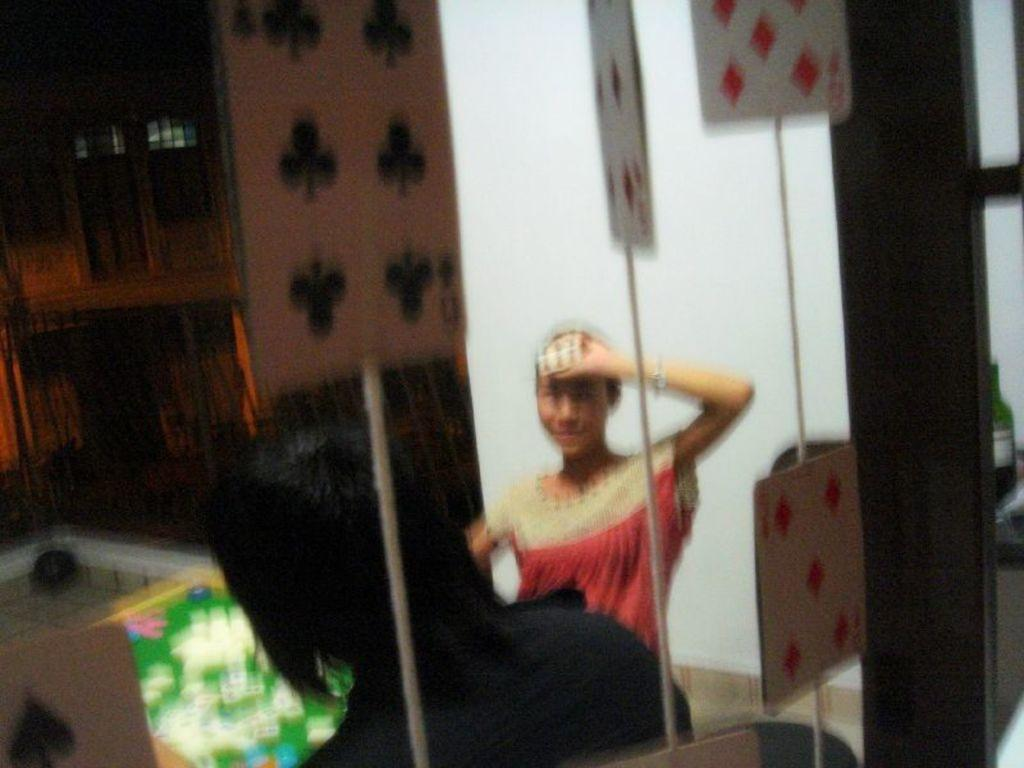How many people are in the image? There are two persons in the image. Can you describe one of the persons in the image? One of the persons is a woman. What is the woman doing with her hand in the image? The woman is holding a card with her hand. What can be seen in the background of the image? There are poles and windows visible in the background of the image. What type of home can be seen in the wilderness in the image? There is no home or wilderness present in the image. What order are the persons following in the image? There is no indication of an order or sequence of actions in the image. 